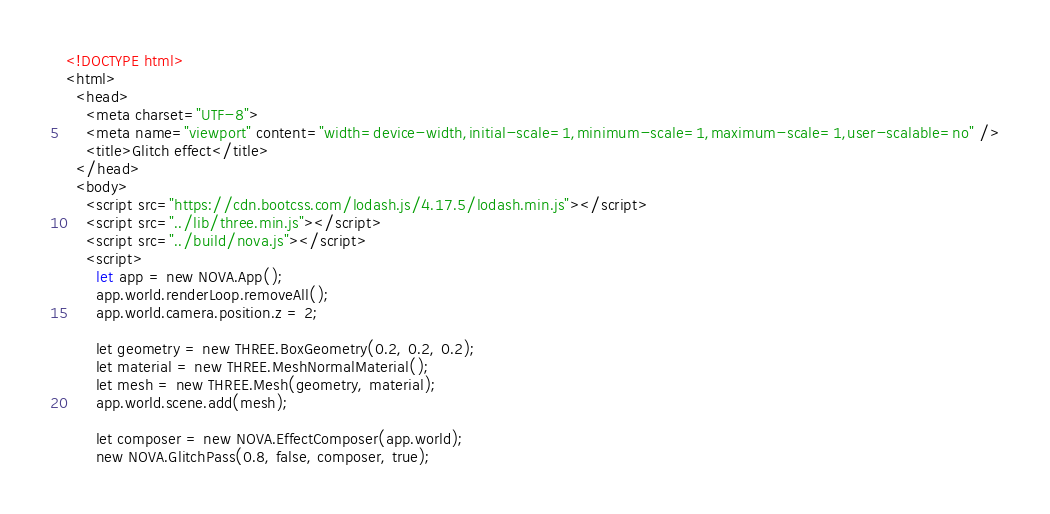Convert code to text. <code><loc_0><loc_0><loc_500><loc_500><_HTML_><!DOCTYPE html>
<html>
  <head>
    <meta charset="UTF-8">
    <meta name="viewport" content="width=device-width,initial-scale=1,minimum-scale=1,maximum-scale=1,user-scalable=no" />
    <title>Glitch effect</title>
  </head>
  <body>
    <script src="https://cdn.bootcss.com/lodash.js/4.17.5/lodash.min.js"></script>
    <script src="../lib/three.min.js"></script>
    <script src="../build/nova.js"></script>
    <script>
      let app = new NOVA.App();
      app.world.renderLoop.removeAll();
      app.world.camera.position.z = 2;

      let geometry = new THREE.BoxGeometry(0.2, 0.2, 0.2);
      let material = new THREE.MeshNormalMaterial();
      let mesh = new THREE.Mesh(geometry, material);
      app.world.scene.add(mesh);

      let composer = new NOVA.EffectComposer(app.world);
      new NOVA.GlitchPass(0.8, false, composer, true);
</code> 